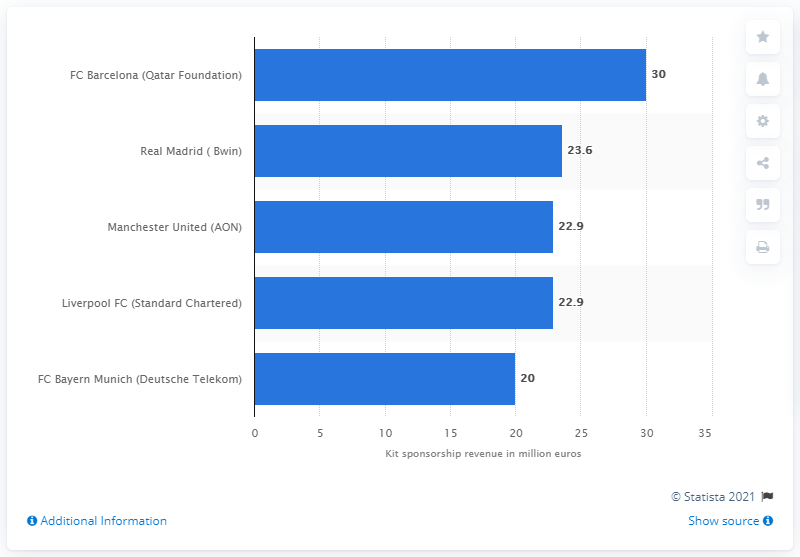Point out several critical features in this image. In the 2011/12 season, Real Madrid received $23.6 million from its kit sponsorship deal with Bwin. 